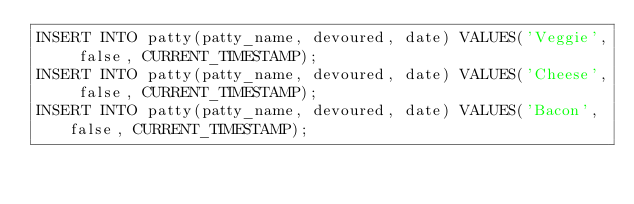Convert code to text. <code><loc_0><loc_0><loc_500><loc_500><_SQL_>INSERT INTO patty(patty_name, devoured, date) VALUES('Veggie', false, CURRENT_TIMESTAMP);
INSERT INTO patty(patty_name, devoured, date) VALUES('Cheese', false, CURRENT_TIMESTAMP);
INSERT INTO patty(patty_name, devoured, date) VALUES('Bacon', false, CURRENT_TIMESTAMP);</code> 